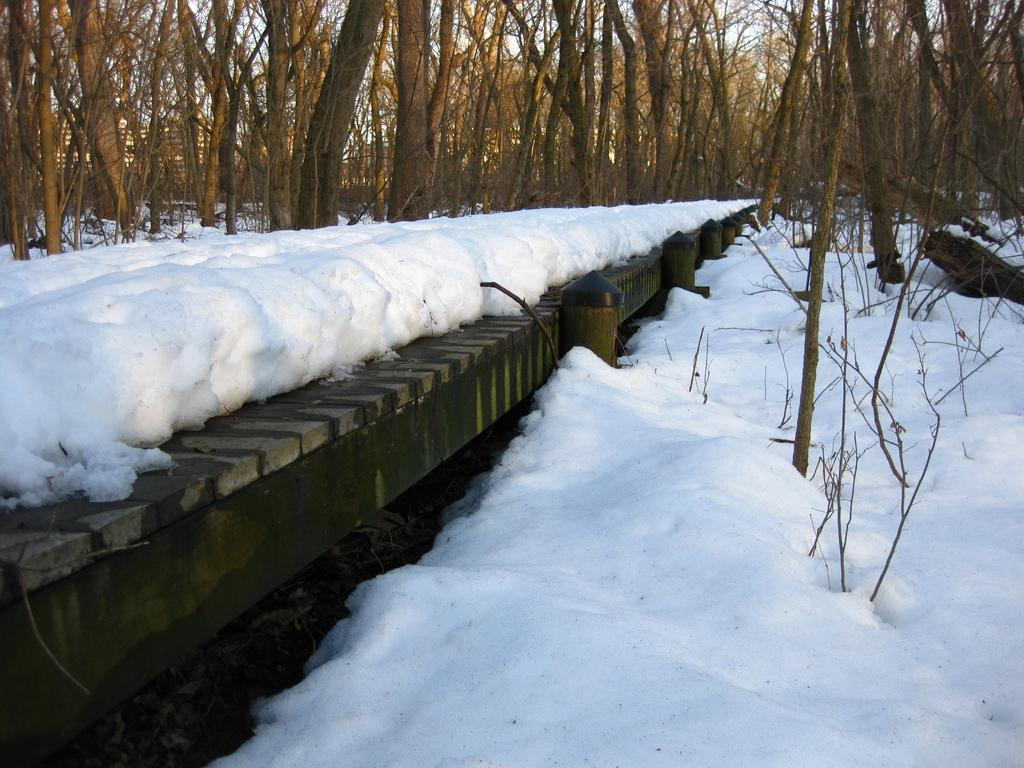What structure can be seen in the image? There is a bridge in the image. What type of weather is depicted in the image? There is snow in the image. What can be seen in the background of the image? There are trees in the background of the image. What type of bells can be heard ringing in the image? There are no bells present in the image, and therefore no sound can be heard. 